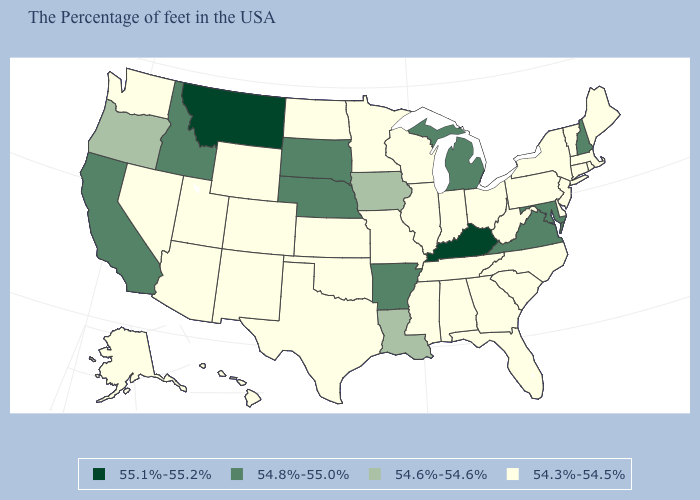What is the value of Delaware?
Write a very short answer. 54.3%-54.5%. Which states have the highest value in the USA?
Concise answer only. Kentucky, Montana. Which states hav the highest value in the West?
Keep it brief. Montana. What is the value of Hawaii?
Short answer required. 54.3%-54.5%. What is the lowest value in the USA?
Answer briefly. 54.3%-54.5%. What is the lowest value in the USA?
Keep it brief. 54.3%-54.5%. What is the lowest value in the Northeast?
Short answer required. 54.3%-54.5%. Does the map have missing data?
Short answer required. No. What is the value of Alabama?
Keep it brief. 54.3%-54.5%. Is the legend a continuous bar?
Answer briefly. No. What is the value of Vermont?
Be succinct. 54.3%-54.5%. What is the lowest value in the MidWest?
Be succinct. 54.3%-54.5%. Name the states that have a value in the range 55.1%-55.2%?
Short answer required. Kentucky, Montana. What is the value of Virginia?
Write a very short answer. 54.8%-55.0%. Among the states that border Minnesota , which have the highest value?
Write a very short answer. South Dakota. 